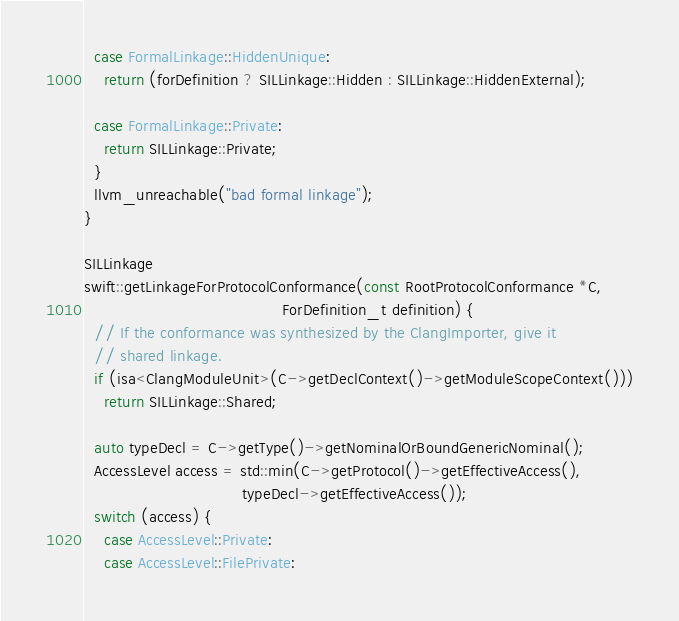Convert code to text. <code><loc_0><loc_0><loc_500><loc_500><_C++_>  case FormalLinkage::HiddenUnique:
    return (forDefinition ? SILLinkage::Hidden : SILLinkage::HiddenExternal);

  case FormalLinkage::Private:
    return SILLinkage::Private;
  }
  llvm_unreachable("bad formal linkage");
}

SILLinkage
swift::getLinkageForProtocolConformance(const RootProtocolConformance *C,
                                        ForDefinition_t definition) {
  // If the conformance was synthesized by the ClangImporter, give it
  // shared linkage.
  if (isa<ClangModuleUnit>(C->getDeclContext()->getModuleScopeContext()))
    return SILLinkage::Shared;

  auto typeDecl = C->getType()->getNominalOrBoundGenericNominal();
  AccessLevel access = std::min(C->getProtocol()->getEffectiveAccess(),
                                typeDecl->getEffectiveAccess());
  switch (access) {
    case AccessLevel::Private:
    case AccessLevel::FilePrivate:</code> 